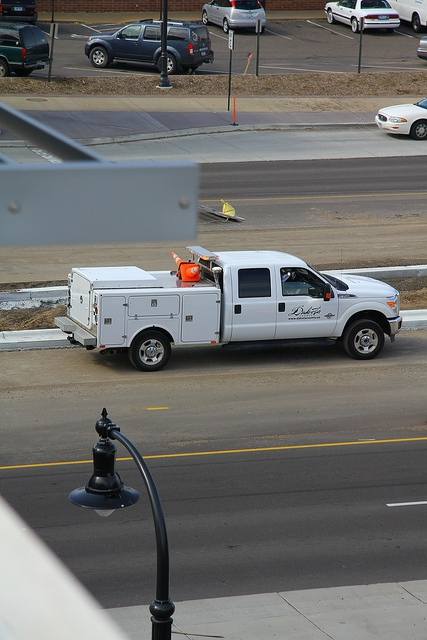Describe the objects in this image and their specific colors. I can see truck in gray, darkgray, black, and lightgray tones, car in gray, black, navy, and blue tones, car in gray, black, darkblue, and blue tones, car in gray, black, lightgray, and darkgray tones, and car in gray, black, and darkgray tones in this image. 